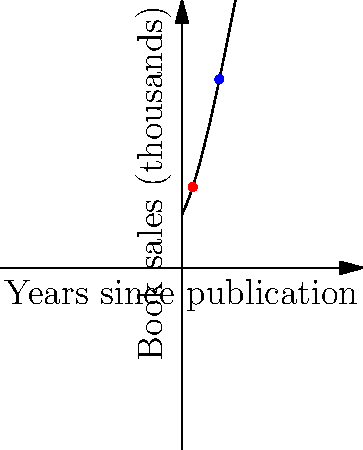The polynomial graph represents book sales (in thousands) for a classic heavy metal-inspired novel over time. If the function is of the form $f(x) = ax^3 + bx^2 + cx + d$, where $x$ represents years since publication, what is the approximate value of $a$? (Hint: Consider the behavior of the graph as $x$ increases.) To determine the approximate value of $a$, let's analyze the graph:

1. The graph shows an initial increase in book sales, followed by a peak, and then a decline.

2. For a cubic function $f(x) = ax^3 + bx^2 + cx + d$, the term $ax^3$ dominates as $x$ becomes large.

3. The graph is decreasing for large $x$, which suggests that $a$ is negative.

4. The rate of decrease is relatively slow, indicating that the absolute value of $a$ is small.

5. By visual estimation, we can see that the graph decreases by about 10-15 units over the last 3-4 years shown.

6. This suggests that $|a|$ is likely around 0.01, as $0.01 * 10^3 = 10$.

7. Since we determined $a$ is negative, our estimate for $a$ is approximately $-0.01$.
Answer: $a \approx -0.01$ 